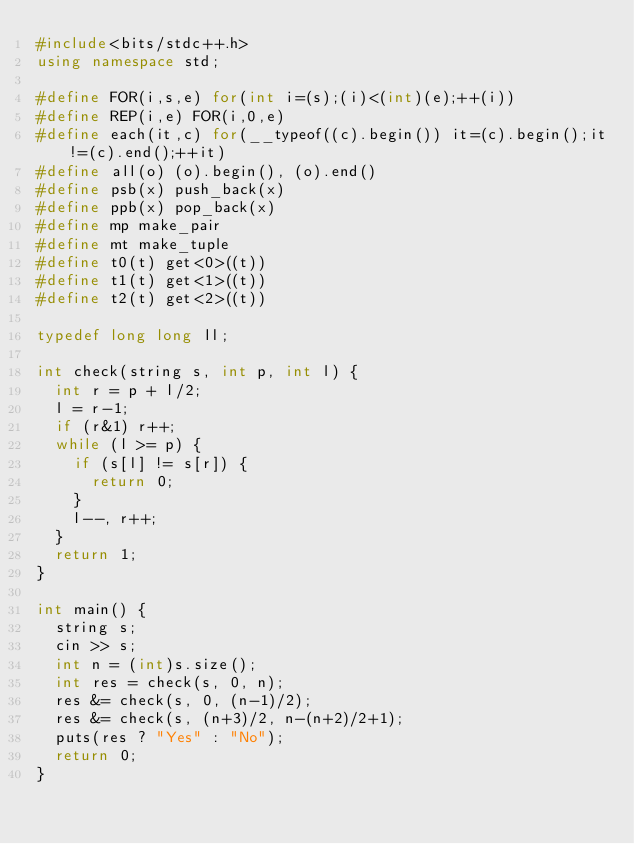<code> <loc_0><loc_0><loc_500><loc_500><_C++_>#include<bits/stdc++.h>
using namespace std;

#define FOR(i,s,e) for(int i=(s);(i)<(int)(e);++(i))
#define REP(i,e) FOR(i,0,e)
#define each(it,c) for(__typeof((c).begin()) it=(c).begin();it!=(c).end();++it)
#define all(o) (o).begin(), (o).end()
#define psb(x) push_back(x)
#define ppb(x) pop_back(x)
#define mp make_pair
#define mt make_tuple
#define t0(t) get<0>((t))
#define t1(t) get<1>((t))
#define t2(t) get<2>((t))

typedef long long ll;

int check(string s, int p, int l) {
  int r = p + l/2;
  l = r-1;
  if (r&1) r++;
  while (l >= p) {
    if (s[l] != s[r]) {
      return 0;
    }
    l--, r++;
  }
  return 1;
}

int main() {
  string s;
  cin >> s;
  int n = (int)s.size();
  int res = check(s, 0, n);
  res &= check(s, 0, (n-1)/2);
  res &= check(s, (n+3)/2, n-(n+2)/2+1);
  puts(res ? "Yes" : "No");
  return 0;
}
</code> 